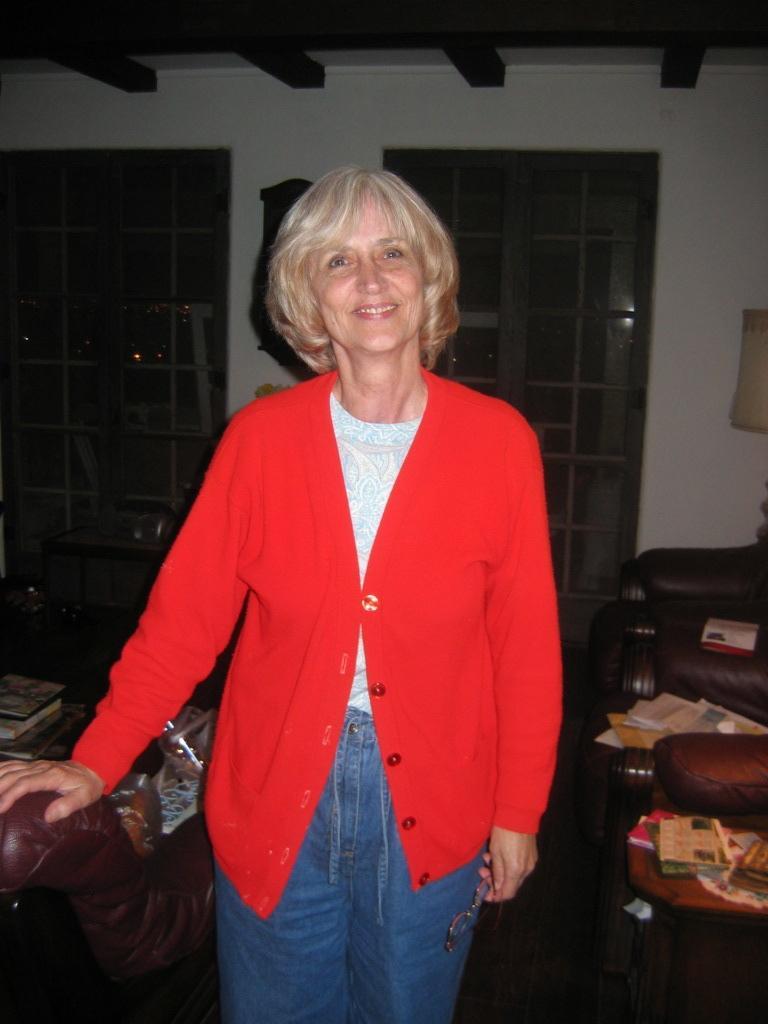Describe this image in one or two sentences. This image is taken in a room with a woman standing wearing a red colour jacket with a smile on her face taking support on a sofa. In the background there is a door,sofa,lamp and center table with a books on it. 